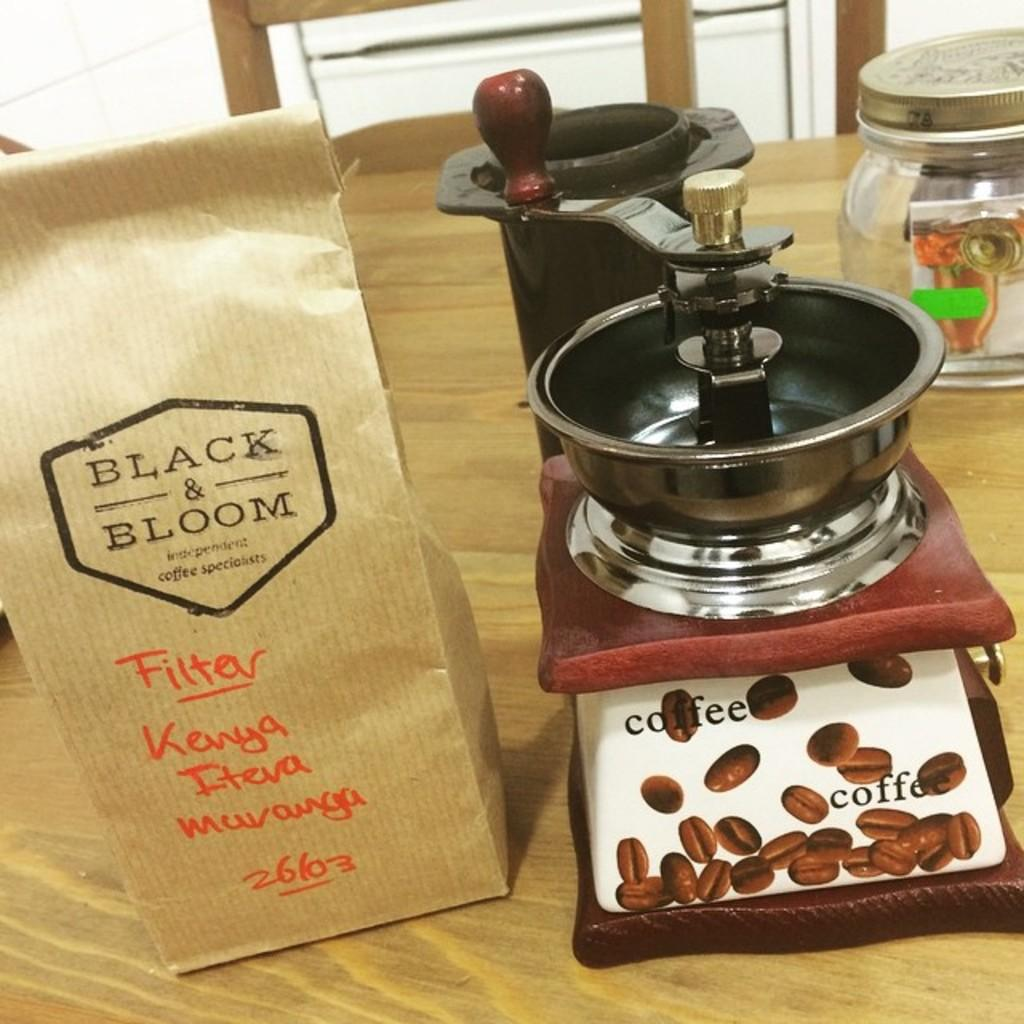<image>
Relay a brief, clear account of the picture shown. A bag of Black & Bloom coffee has hand-written information on it in red ink. 